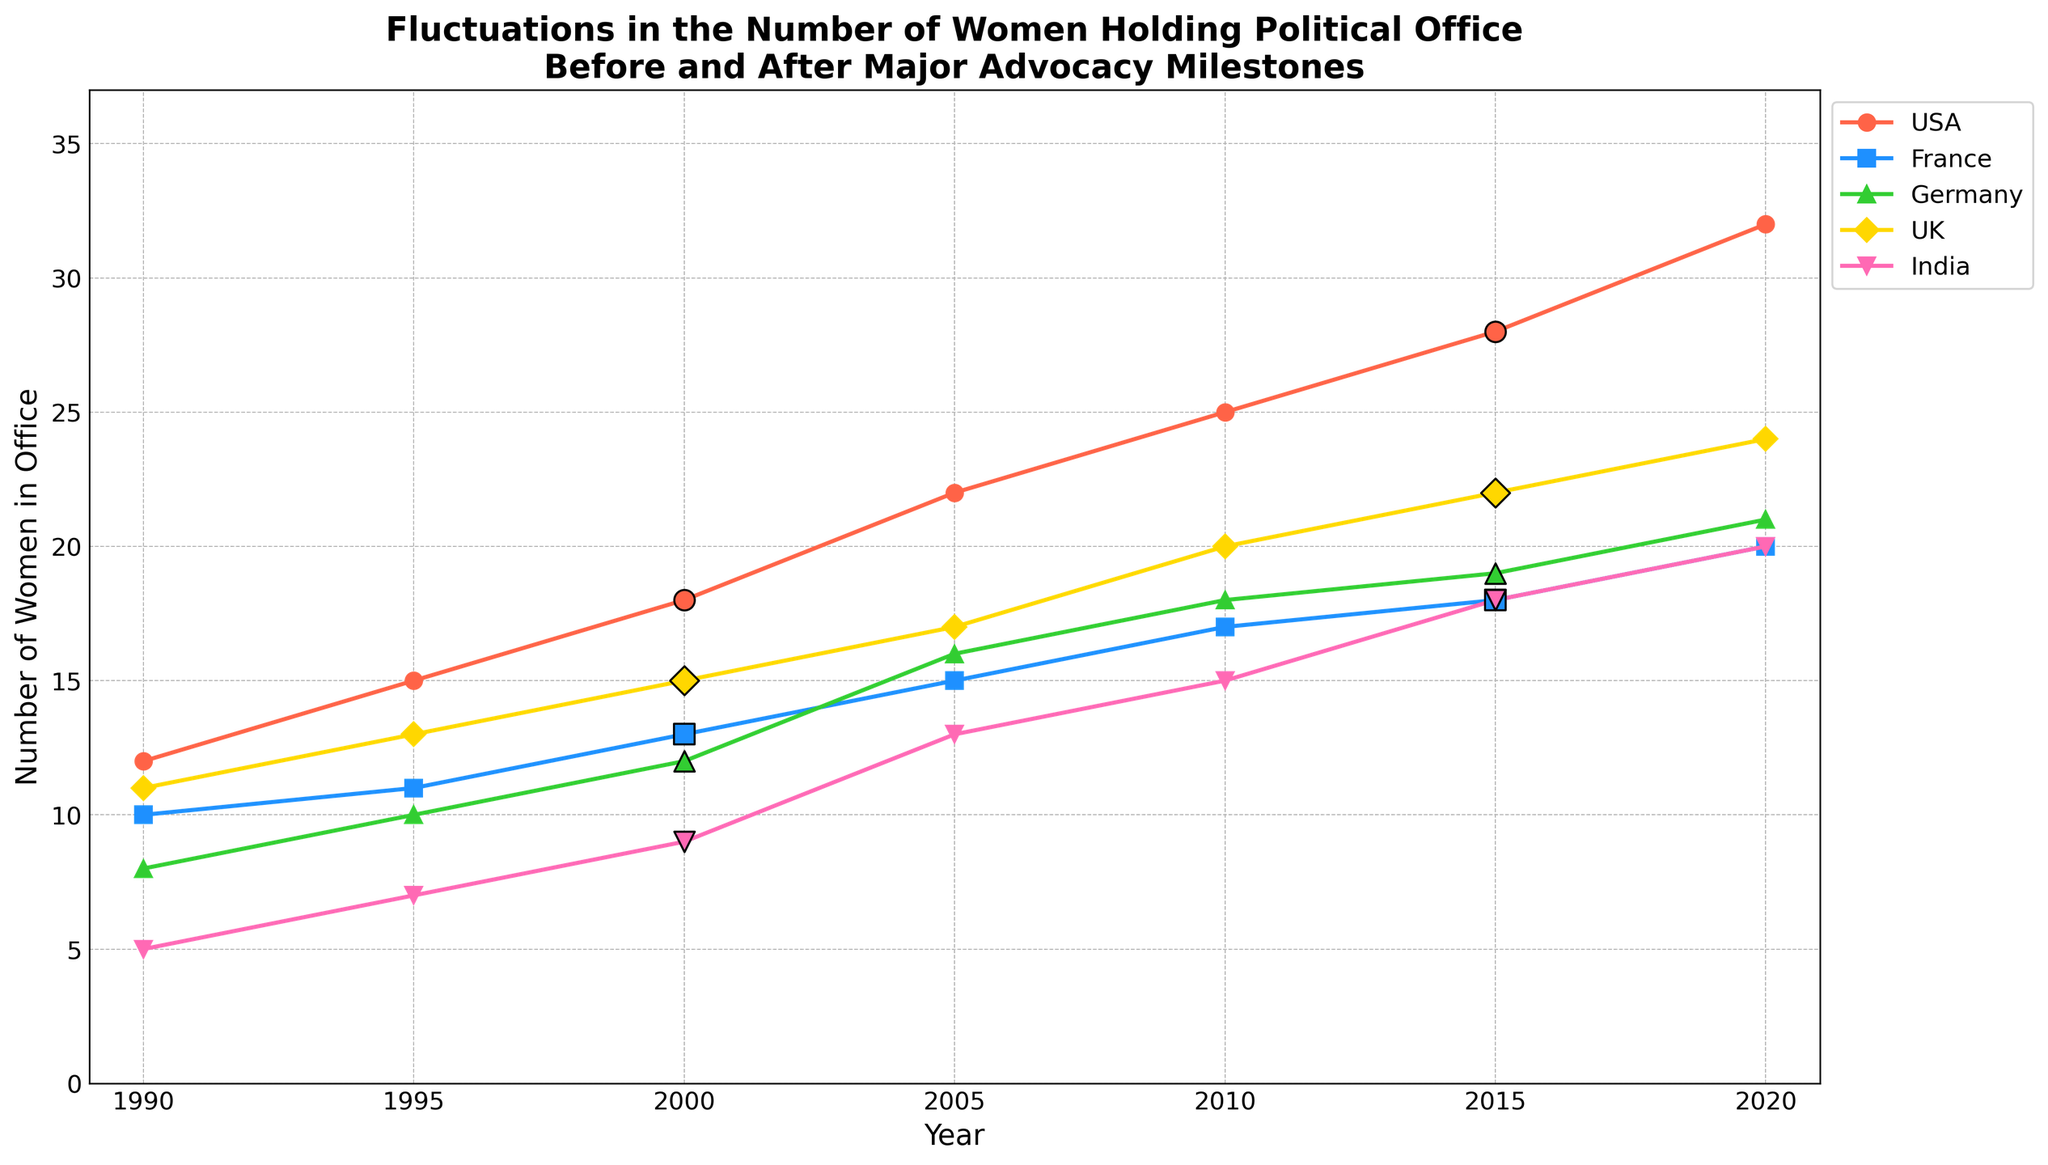What year did the USA have the highest number of women holding political office? By examining the plot, you can see that the USA had the highest number of women holding political office in the year 2020.
Answer: 2020 Compare the number of women in office in France and the UK in the year 2000. Which country had more? Looking at the plot for the year 2000, the number of women in office in France was 13, while in the UK it was 15. Therefore, the UK had more women in office compared to France in 2000.
Answer: UK Did Germany experience a higher increase in the number of women in office between 1990 and 2000 or between 2000 and 2010? From the plot, Germany had 8 women in office in 1990 and 12 in 2000, indicating an increase of 4. From 2000 to 2010, the number increased from 12 to 18, indicating an increase of 6. Therefore, Germany experienced a higher increase between 2000 and 2010.
Answer: 2000 and 2010 For which country did the number of women in office increase the most immediately following an advocacy milestone? By examining the highlighted points indicating advocacy milestones and the subsequent increases, India showed the most significant increase following an advocacy milestone in 2000, rising from 9 in 2000 to 13 in 2005 (an increase of 4).
Answer: India What color represents the data for Germany? The plot uses different colors for each country. Germany is represented in green.
Answer: Green How many advocacy milestones occurred in total in the plotted data? Count the highlighted milestone points on the plot. There is one milestone in each country for the years 2000 and 2015, making a total of 10 advocacy milestones.
Answer: 10 In 2010, which country had the least number of women in office? Observing the plot for the year 2010, India had the least number of women in office, which was 15.
Answer: India What is the overall trend in the number of women in political office across all countries from 1990 to 2020? The plot shows an increasing trend in the number of women in political office across all countries from 1990 to 2020.
Answer: Increasing Compare the rate of increase in the number of women in office in the UK and France from 1990 to 2020. Which country experienced a more rapid increase? From 1990 to 2020, the UK increased from 11 to 24 (13 points), while France increased from 10 to 20 (10 points). The UK experienced a more rapid increase.
Answer: UK 